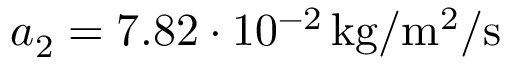<formula> <loc_0><loc_0><loc_500><loc_500>a _ { 2 } = 7 . 8 2 \cdot 1 0 ^ { - 2 } \, k g / m ^ { 2 } / s</formula> 